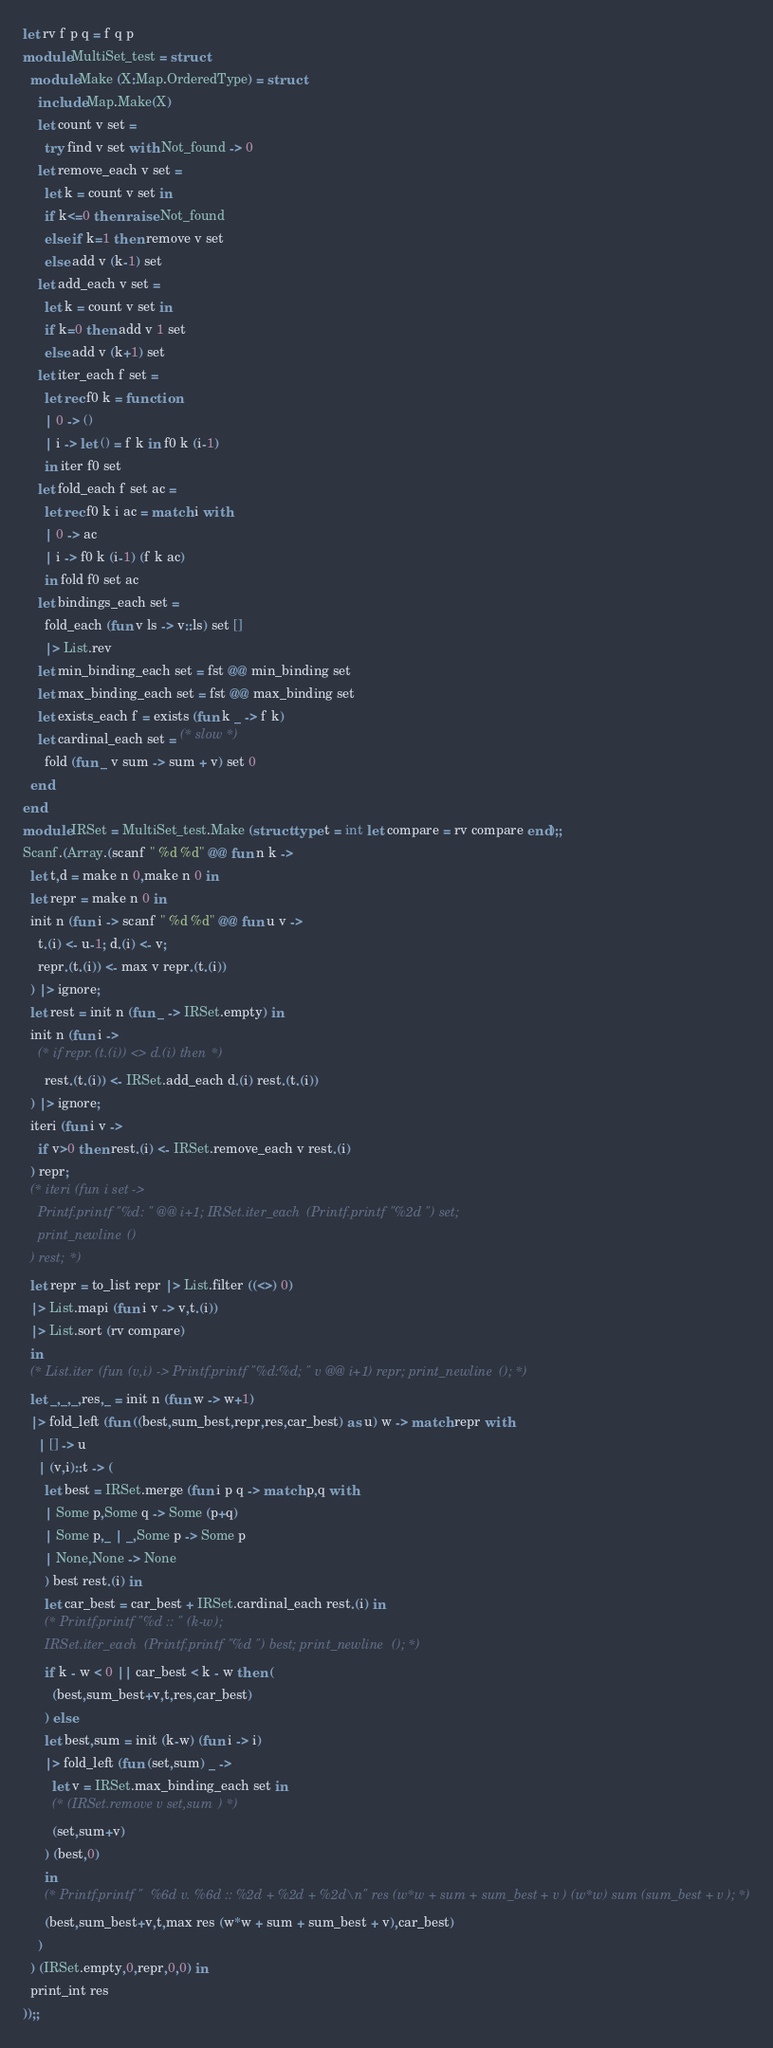<code> <loc_0><loc_0><loc_500><loc_500><_OCaml_>let rv f p q = f q p
module MultiSet_test = struct
  module Make (X:Map.OrderedType) = struct
    include Map.Make(X)
    let count v set =
      try find v set with Not_found -> 0
    let remove_each v set =
      let k = count v set in
      if k<=0 then raise Not_found
      else if k=1 then remove v set
      else add v (k-1) set
    let add_each v set =
      let k = count v set in
      if k=0 then add v 1 set
      else add v (k+1) set
    let iter_each f set =
      let rec f0 k = function
      | 0 -> ()
      | i -> let () = f k in f0 k (i-1)
      in iter f0 set
    let fold_each f set ac =
      let rec f0 k i ac = match i with
      | 0 -> ac
      | i -> f0 k (i-1) (f k ac)
      in fold f0 set ac
    let bindings_each set =
      fold_each (fun v ls -> v::ls) set []
      |> List.rev
    let min_binding_each set = fst @@ min_binding set
    let max_binding_each set = fst @@ max_binding set
    let exists_each f = exists (fun k _ -> f k)
    let cardinal_each set = (* slow *)
      fold (fun _ v sum -> sum + v) set 0
  end
end
module IRSet = MultiSet_test.Make (struct type t = int let compare = rv compare end);;
Scanf.(Array.(scanf " %d %d" @@ fun n k ->
  let t,d = make n 0,make n 0 in
  let repr = make n 0 in
  init n (fun i -> scanf " %d %d" @@ fun u v ->
    t.(i) <- u-1; d.(i) <- v;
    repr.(t.(i)) <- max v repr.(t.(i))
  ) |> ignore;
  let rest = init n (fun _ -> IRSet.empty) in
  init n (fun i ->
    (* if repr.(t.(i)) <> d.(i) then *)
      rest.(t.(i)) <- IRSet.add_each d.(i) rest.(t.(i))
  ) |> ignore;
  iteri (fun i v ->
    if v>0 then rest.(i) <- IRSet.remove_each v rest.(i)
  ) repr;
  (* iteri (fun i set ->
    Printf.printf "%d: " @@ i+1; IRSet.iter_each (Printf.printf "%2d ") set;
    print_newline ()
  ) rest; *)
  let repr = to_list repr |> List.filter ((<>) 0)
  |> List.mapi (fun i v -> v,t.(i))
  |> List.sort (rv compare)
  in
  (* List.iter (fun (v,i) -> Printf.printf "%d:%d; " v @@ i+1) repr; print_newline (); *)
  let _,_,_,res,_ = init n (fun w -> w+1)
  |> fold_left (fun ((best,sum_best,repr,res,car_best) as u) w -> match repr with
    | [] -> u
    | (v,i)::t -> (
      let best = IRSet.merge (fun i p q -> match p,q with
      | Some p,Some q -> Some (p+q)
      | Some p,_ | _,Some p -> Some p
      | None,None -> None
      ) best rest.(i) in
      let car_best = car_best + IRSet.cardinal_each rest.(i) in
      (* Printf.printf "%d :: " (k-w);
      IRSet.iter_each (Printf.printf "%d ") best; print_newline (); *)
      if k - w < 0 || car_best < k - w then (
        (best,sum_best+v,t,res,car_best)
      ) else
      let best,sum = init (k-w) (fun i -> i)
      |> fold_left (fun (set,sum) _ ->
        let v = IRSet.max_binding_each set in
        (* (IRSet.remove v set,sum) *)
        (set,sum+v)
      ) (best,0)
      in
      (* Printf.printf "  %6d v. %6d :: %2d + %2d + %2d\n" res (w*w + sum + sum_best + v) (w*w) sum (sum_best + v); *)
      (best,sum_best+v,t,max res (w*w + sum + sum_best + v),car_best)
    )
  ) (IRSet.empty,0,repr,0,0) in
  print_int res
));;
</code> 